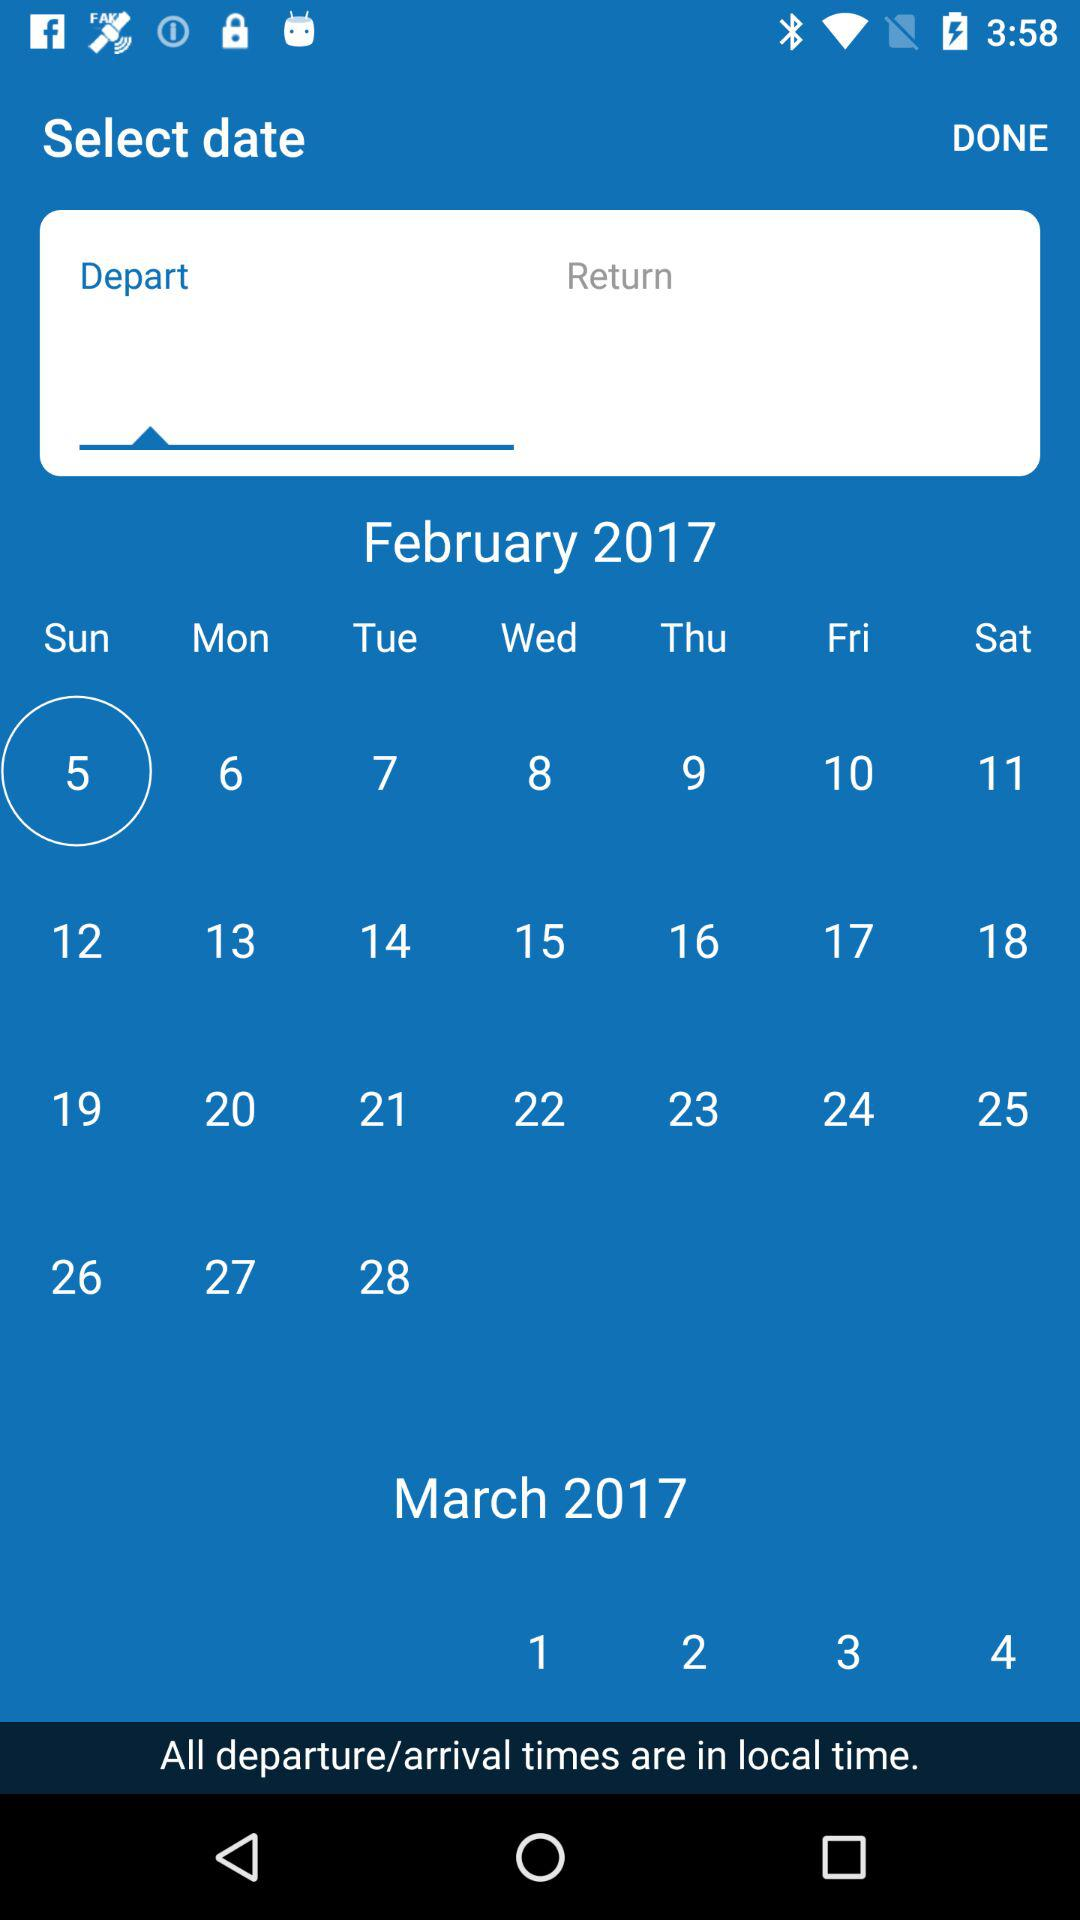What is the selected date? The selected date is Sunday, February 5, 2017. 